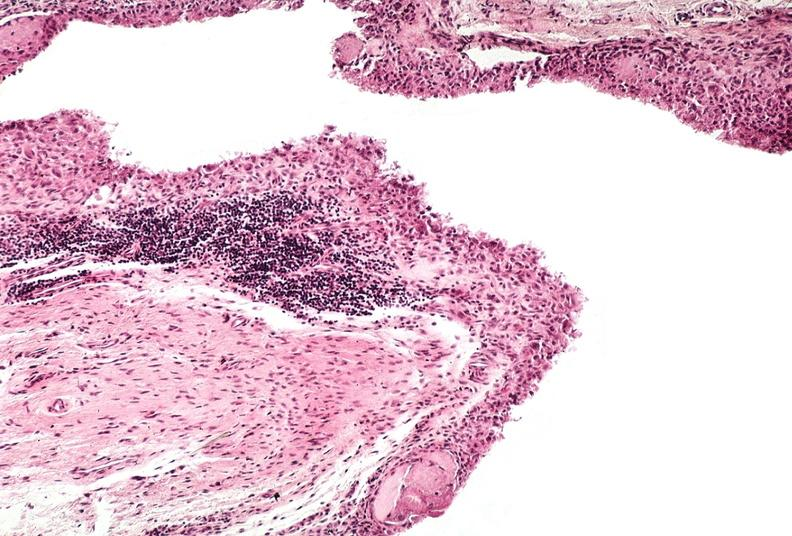s joints present?
Answer the question using a single word or phrase. Yes 